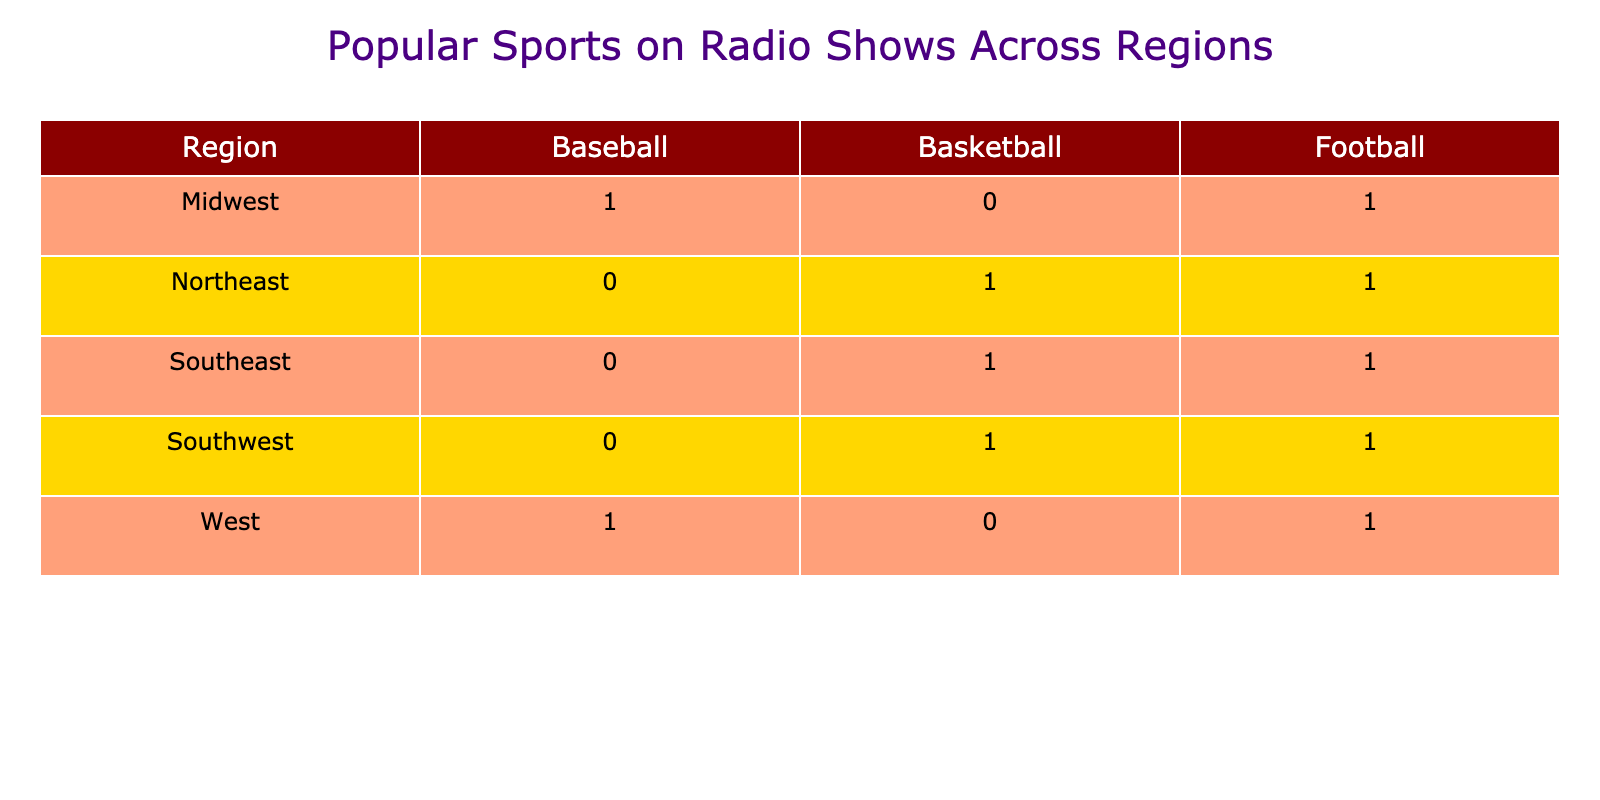What is the most popular sport in the Northeast region? The table shows that in the Northeast, both football and basketball are popular sports. However, the question specifically asks for the most popular one, which is often based on context or frequency of mention. Here, it is reasonable to consider football (mentioned first) as the lead sport.
Answer: Football How many sports are popular in the Midwest? Looking at the Midwest row, there are two sports listed: baseball and football. Therefore, we can simply count the entries to determine that there are two popular sports.
Answer: 2 Is basketball popular in the Southwest region? By examining the Southwest row, we find that it lists basketball and football. Therefore, the answer is affirmative since basketball is indeed mentioned as a popular sport.
Answer: Yes Which region has football and baseball as popular sports? The table indicates that football appears in the Northeast, Southeast, Midwest, Southwest, and West regions, while baseball is only found in the Midwest and West. Since baseball and football don't appear together in any single region, we conclude there is no such region.
Answer: None What is the total number of instances of football mentioned across all regions? By scanning the table, we find football is present in the Northeast, Southeast, Midwest, Southwest, and West regions, amounting to five instances: 1 in Northeast, 1 in Southeast, 1 in Midwest, 1 in Southwest, and 1 in West. Therefore, the total is 5.
Answer: 5 